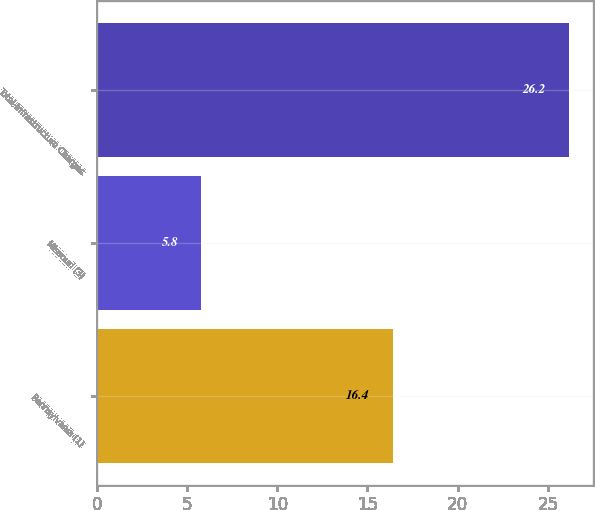Convert chart. <chart><loc_0><loc_0><loc_500><loc_500><bar_chart><fcel>Pennsylvania (1)<fcel>Missouri (3)<fcel>Total-Infrastructure Charges<nl><fcel>16.4<fcel>5.8<fcel>26.2<nl></chart> 